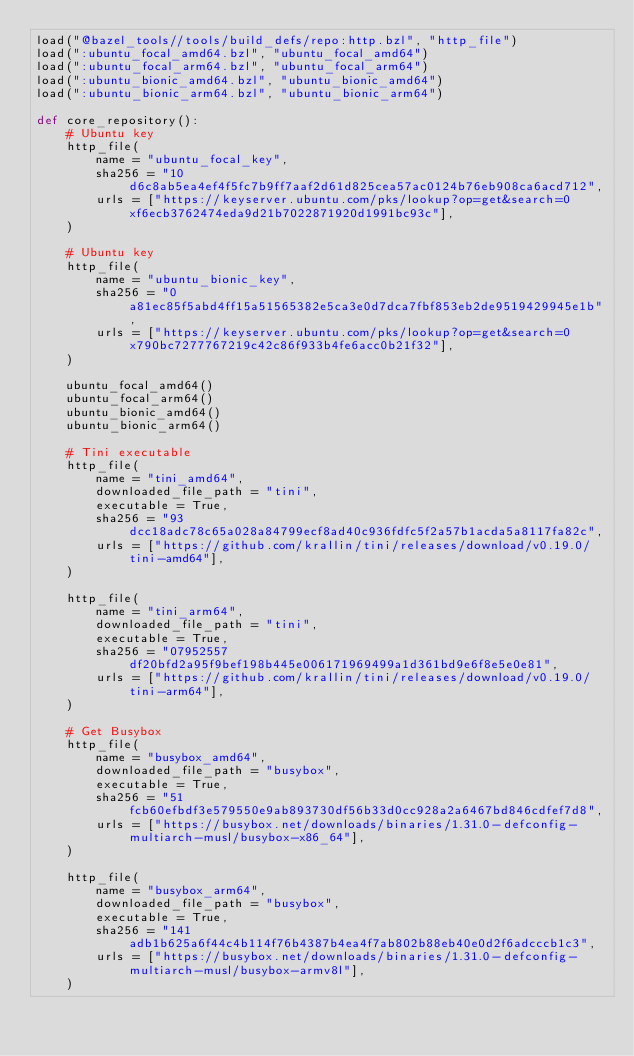Convert code to text. <code><loc_0><loc_0><loc_500><loc_500><_Python_>load("@bazel_tools//tools/build_defs/repo:http.bzl", "http_file")
load(":ubuntu_focal_amd64.bzl", "ubuntu_focal_amd64")
load(":ubuntu_focal_arm64.bzl", "ubuntu_focal_arm64")
load(":ubuntu_bionic_amd64.bzl", "ubuntu_bionic_amd64")
load(":ubuntu_bionic_arm64.bzl", "ubuntu_bionic_arm64")

def core_repository():
    # Ubuntu key
    http_file(
        name = "ubuntu_focal_key",
        sha256 = "10d6c8ab5ea4ef4f5fc7b9ff7aaf2d61d825cea57ac0124b76eb908ca6acd712",
        urls = ["https://keyserver.ubuntu.com/pks/lookup?op=get&search=0xf6ecb3762474eda9d21b7022871920d1991bc93c"],
    )

    # Ubuntu key
    http_file(
        name = "ubuntu_bionic_key",
        sha256 = "0a81ec85f5abd4ff15a51565382e5ca3e0d7dca7fbf853eb2de9519429945e1b",
        urls = ["https://keyserver.ubuntu.com/pks/lookup?op=get&search=0x790bc7277767219c42c86f933b4fe6acc0b21f32"],
    )

    ubuntu_focal_amd64()
    ubuntu_focal_arm64()
    ubuntu_bionic_amd64()
    ubuntu_bionic_arm64()

    # Tini executable
    http_file(
        name = "tini_amd64",
        downloaded_file_path = "tini",
        executable = True,
        sha256 = "93dcc18adc78c65a028a84799ecf8ad40c936fdfc5f2a57b1acda5a8117fa82c",
        urls = ["https://github.com/krallin/tini/releases/download/v0.19.0/tini-amd64"],
    )

    http_file(
        name = "tini_arm64",
        downloaded_file_path = "tini",
        executable = True,
        sha256 = "07952557df20bfd2a95f9bef198b445e006171969499a1d361bd9e6f8e5e0e81",
        urls = ["https://github.com/krallin/tini/releases/download/v0.19.0/tini-arm64"],
    )

    # Get Busybox
    http_file(
        name = "busybox_amd64",
        downloaded_file_path = "busybox",
        executable = True,
        sha256 = "51fcb60efbdf3e579550e9ab893730df56b33d0cc928a2a6467bd846cdfef7d8",
        urls = ["https://busybox.net/downloads/binaries/1.31.0-defconfig-multiarch-musl/busybox-x86_64"],
    )

    http_file(
        name = "busybox_arm64",
        downloaded_file_path = "busybox",
        executable = True,
        sha256 = "141adb1b625a6f44c4b114f76b4387b4ea4f7ab802b88eb40e0d2f6adcccb1c3",
        urls = ["https://busybox.net/downloads/binaries/1.31.0-defconfig-multiarch-musl/busybox-armv8l"],
    )
</code> 